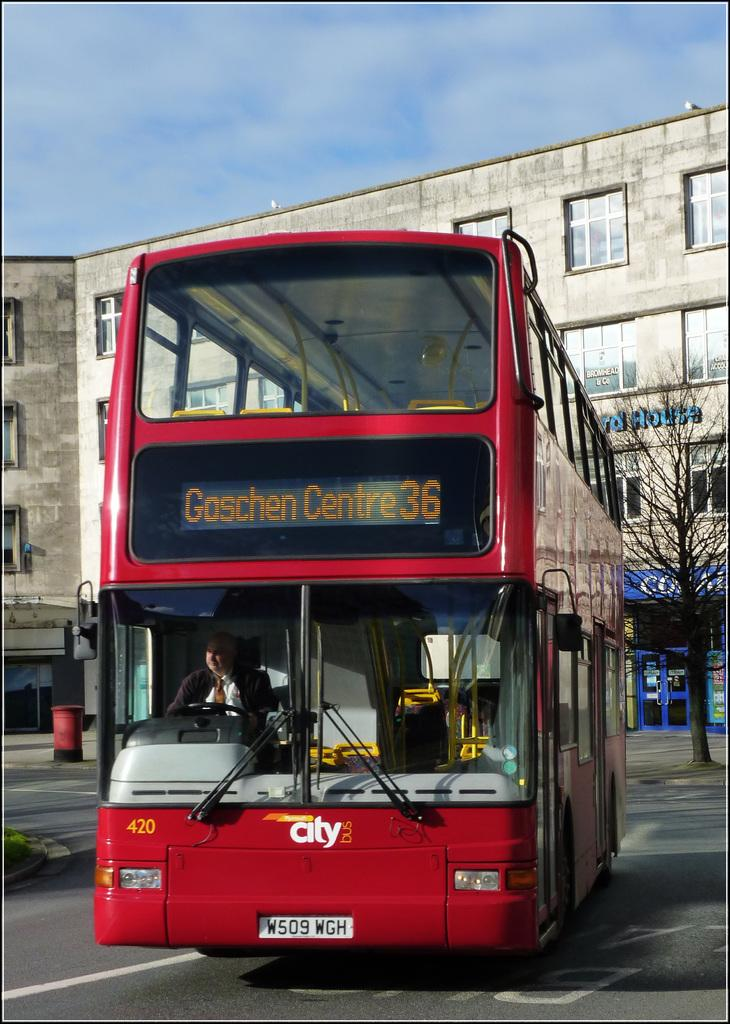Provide a one-sentence caption for the provided image. A bus numbered 420 is on the street. 